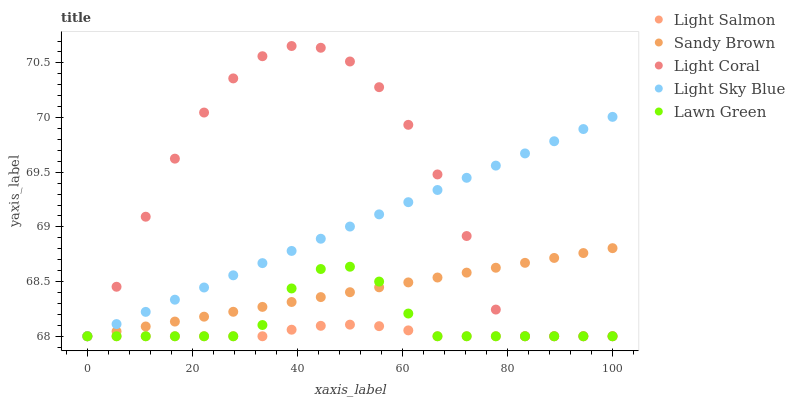Does Light Salmon have the minimum area under the curve?
Answer yes or no. Yes. Does Light Coral have the maximum area under the curve?
Answer yes or no. Yes. Does Lawn Green have the minimum area under the curve?
Answer yes or no. No. Does Lawn Green have the maximum area under the curve?
Answer yes or no. No. Is Light Sky Blue the smoothest?
Answer yes or no. Yes. Is Light Coral the roughest?
Answer yes or no. Yes. Is Lawn Green the smoothest?
Answer yes or no. No. Is Lawn Green the roughest?
Answer yes or no. No. Does Light Coral have the lowest value?
Answer yes or no. Yes. Does Light Coral have the highest value?
Answer yes or no. Yes. Does Lawn Green have the highest value?
Answer yes or no. No. Does Lawn Green intersect Light Sky Blue?
Answer yes or no. Yes. Is Lawn Green less than Light Sky Blue?
Answer yes or no. No. Is Lawn Green greater than Light Sky Blue?
Answer yes or no. No. 